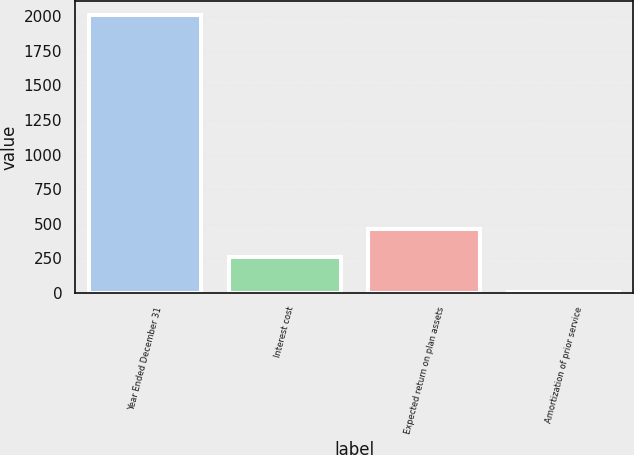Convert chart. <chart><loc_0><loc_0><loc_500><loc_500><bar_chart><fcel>Year Ended December 31<fcel>Interest cost<fcel>Expected return on plan assets<fcel>Amortization of prior service<nl><fcel>2010<fcel>260<fcel>460.5<fcel>5<nl></chart> 